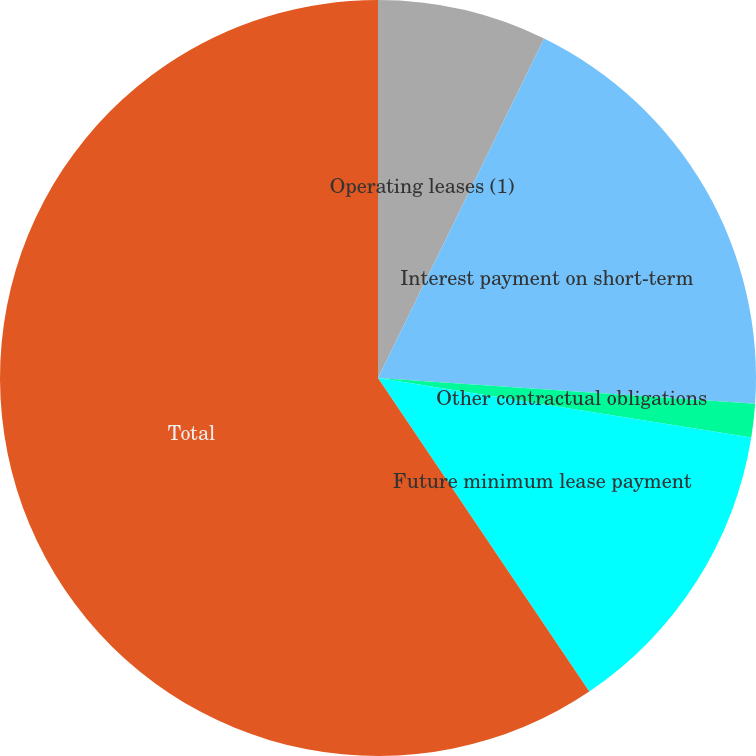Convert chart to OTSL. <chart><loc_0><loc_0><loc_500><loc_500><pie_chart><fcel>Operating leases (1)<fcel>Interest payment on short-term<fcel>Other contractual obligations<fcel>Future minimum lease payment<fcel>Total<nl><fcel>7.24%<fcel>18.84%<fcel>1.44%<fcel>13.04%<fcel>59.44%<nl></chart> 